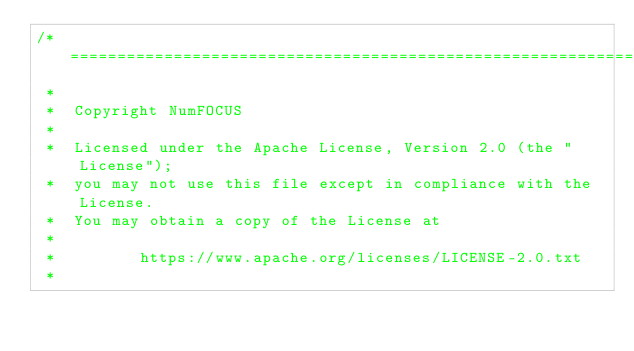<code> <loc_0><loc_0><loc_500><loc_500><_C++_>/*=========================================================================
 *
 *  Copyright NumFOCUS
 *
 *  Licensed under the Apache License, Version 2.0 (the "License");
 *  you may not use this file except in compliance with the License.
 *  You may obtain a copy of the License at
 *
 *         https://www.apache.org/licenses/LICENSE-2.0.txt
 *</code> 